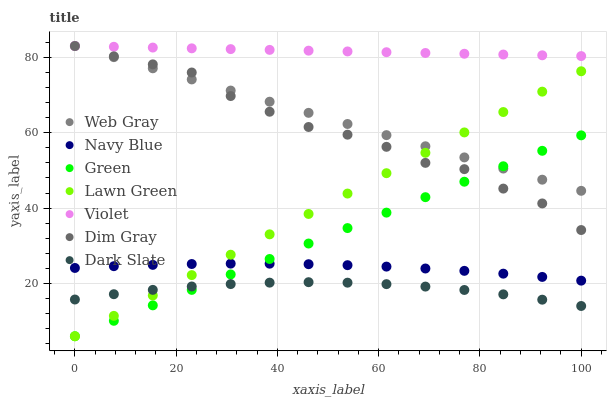Does Dark Slate have the minimum area under the curve?
Answer yes or no. Yes. Does Violet have the maximum area under the curve?
Answer yes or no. Yes. Does Dim Gray have the minimum area under the curve?
Answer yes or no. No. Does Dim Gray have the maximum area under the curve?
Answer yes or no. No. Is Green the smoothest?
Answer yes or no. Yes. Is Dim Gray the roughest?
Answer yes or no. Yes. Is Navy Blue the smoothest?
Answer yes or no. No. Is Navy Blue the roughest?
Answer yes or no. No. Does Lawn Green have the lowest value?
Answer yes or no. Yes. Does Dim Gray have the lowest value?
Answer yes or no. No. Does Violet have the highest value?
Answer yes or no. Yes. Does Navy Blue have the highest value?
Answer yes or no. No. Is Navy Blue less than Web Gray?
Answer yes or no. Yes. Is Dim Gray greater than Dark Slate?
Answer yes or no. Yes. Does Dark Slate intersect Lawn Green?
Answer yes or no. Yes. Is Dark Slate less than Lawn Green?
Answer yes or no. No. Is Dark Slate greater than Lawn Green?
Answer yes or no. No. Does Navy Blue intersect Web Gray?
Answer yes or no. No. 